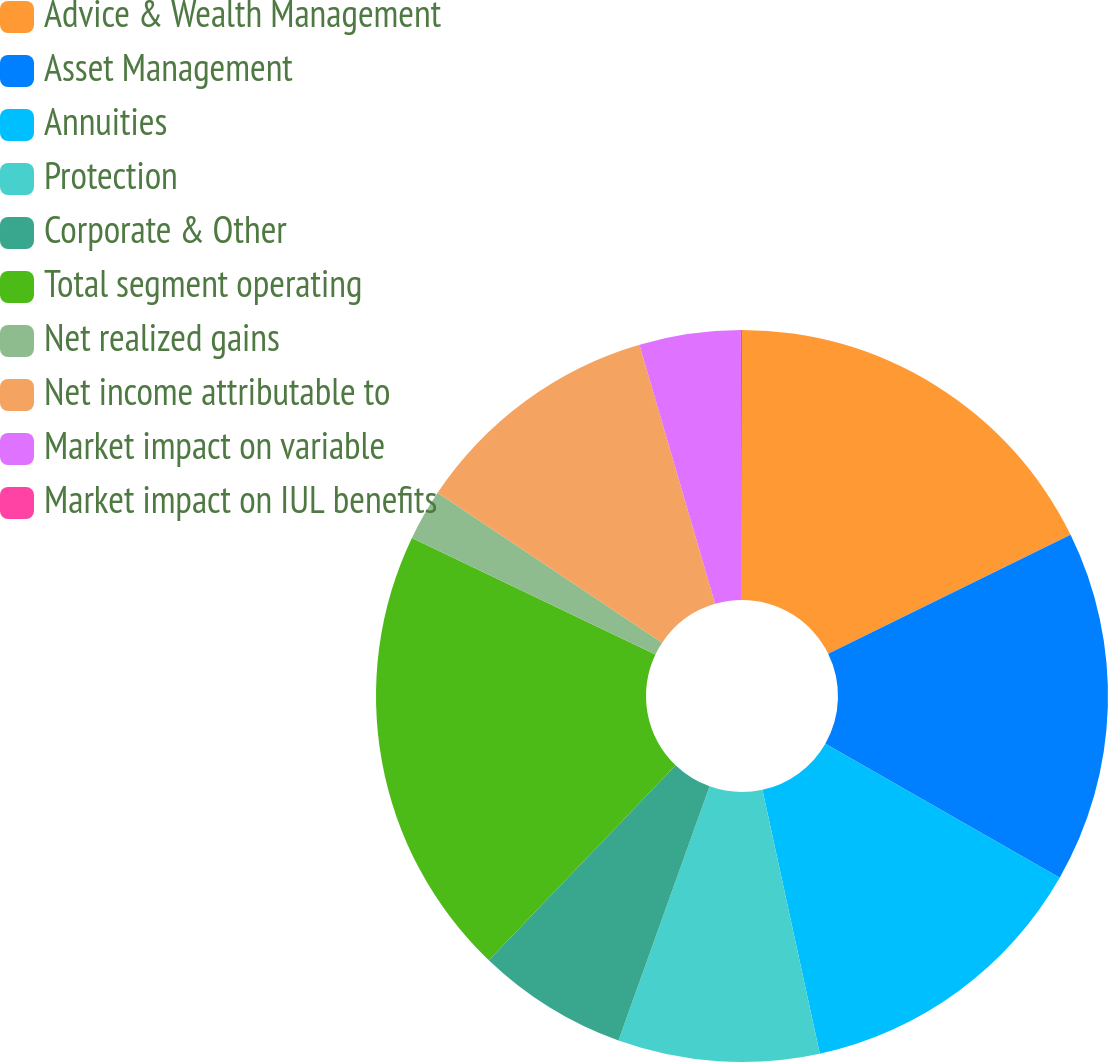Convert chart. <chart><loc_0><loc_0><loc_500><loc_500><pie_chart><fcel>Advice & Wealth Management<fcel>Asset Management<fcel>Annuities<fcel>Protection<fcel>Corporate & Other<fcel>Total segment operating<fcel>Net realized gains<fcel>Net income attributable to<fcel>Market impact on variable<fcel>Market impact on IUL benefits<nl><fcel>17.74%<fcel>15.53%<fcel>13.32%<fcel>8.89%<fcel>6.68%<fcel>19.95%<fcel>2.26%<fcel>11.11%<fcel>4.47%<fcel>0.05%<nl></chart> 